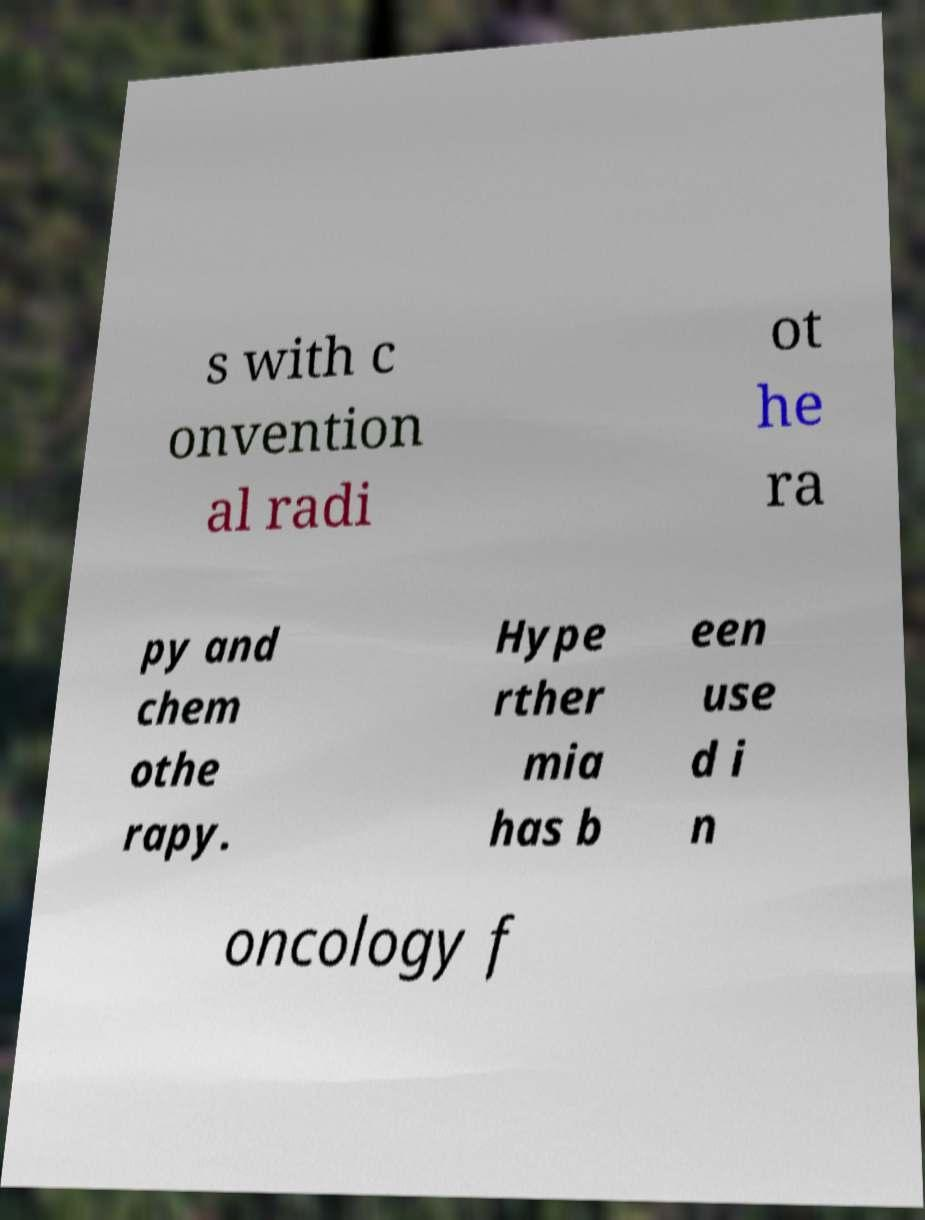What messages or text are displayed in this image? I need them in a readable, typed format. s with c onvention al radi ot he ra py and chem othe rapy. Hype rther mia has b een use d i n oncology f 